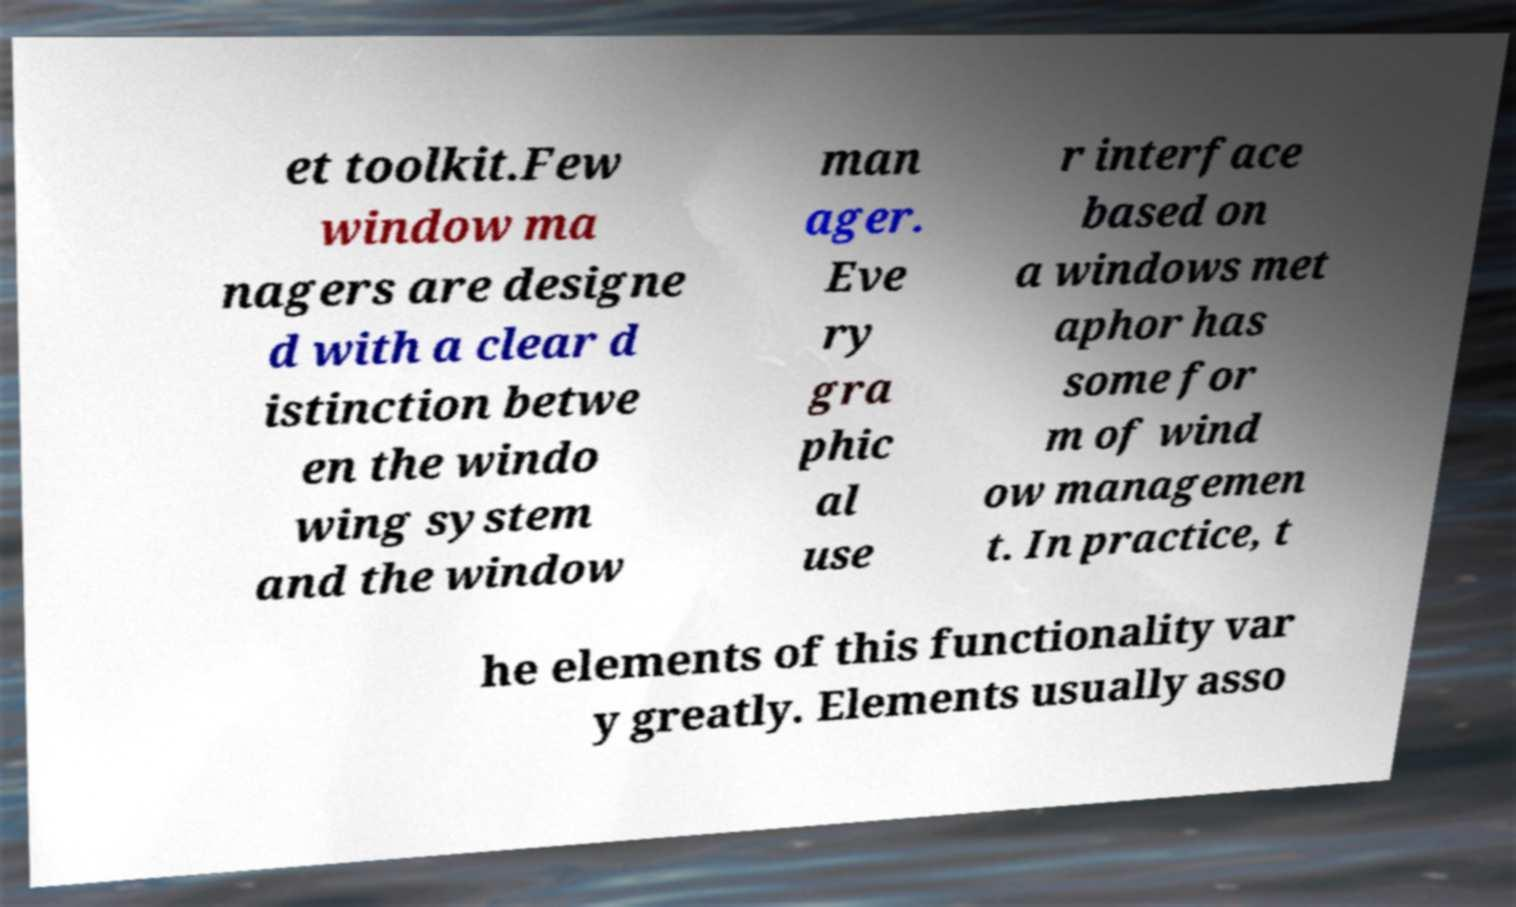For documentation purposes, I need the text within this image transcribed. Could you provide that? et toolkit.Few window ma nagers are designe d with a clear d istinction betwe en the windo wing system and the window man ager. Eve ry gra phic al use r interface based on a windows met aphor has some for m of wind ow managemen t. In practice, t he elements of this functionality var y greatly. Elements usually asso 